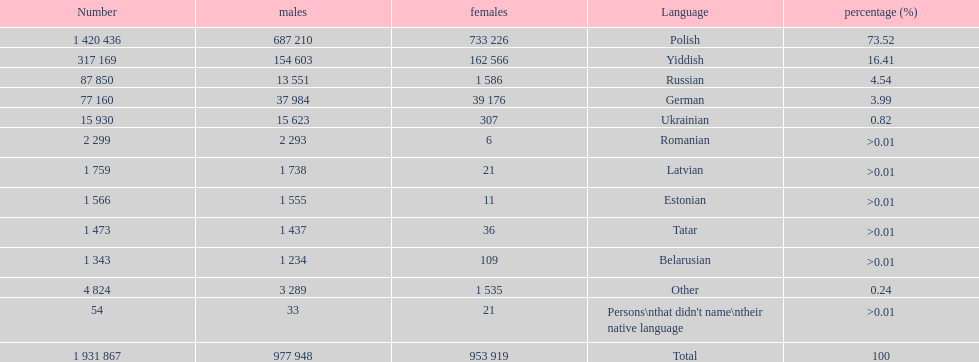What was the top language from the one's whose percentage was >0.01 Romanian. 